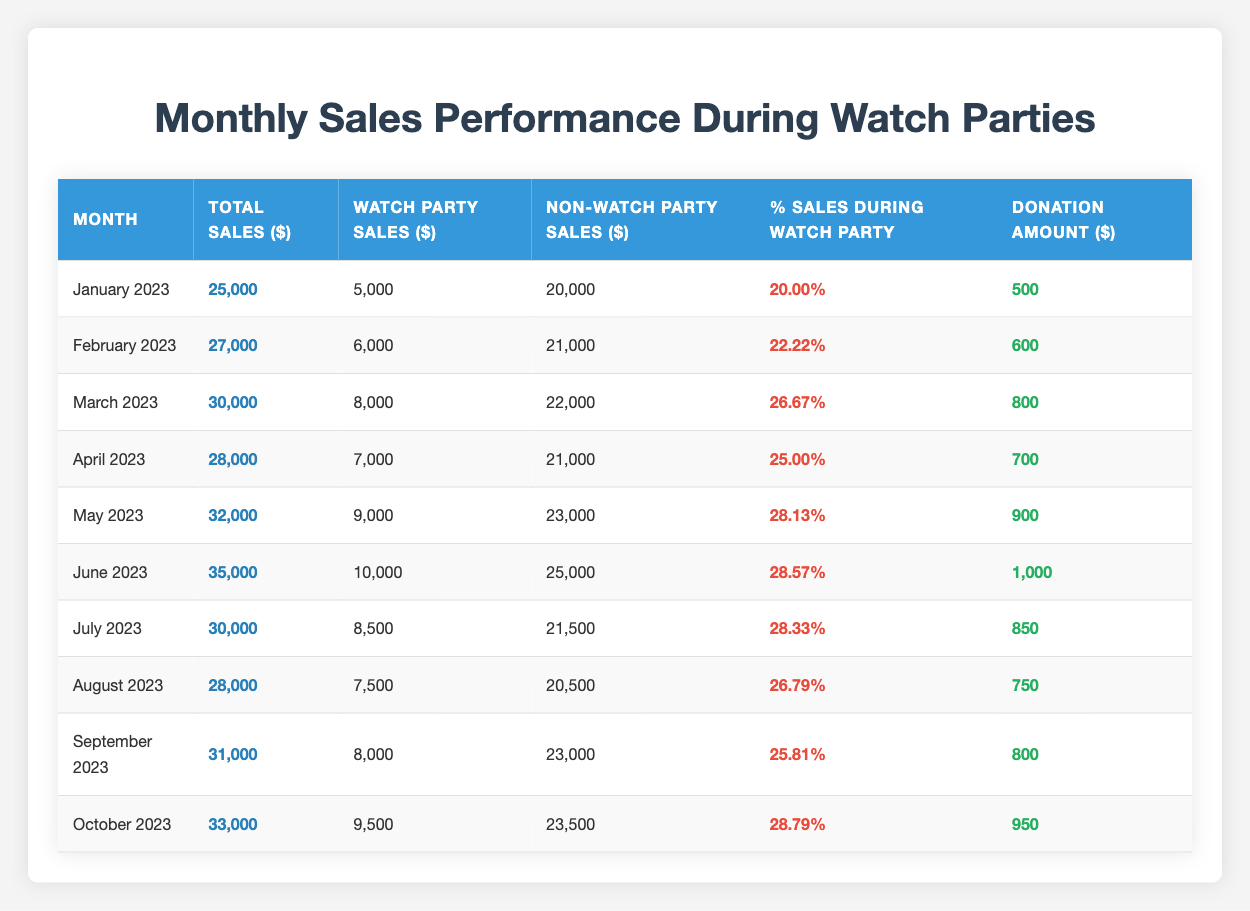What were the total sales for June 2023? In the table, find the row for June 2023, and look at the value under the Total Sales column. It indicates that the total sales for that month were 35000.
Answer: 35000 What percentage of sales during May 2023 came from watch parties? Referring to the May 2023 row in the table, the value under the % Sales During Watch Party column shows that 28.13% of the total sales came from watch parties.
Answer: 28.13% Which month had the highest watch party sales? By examining the Watch Party Sales column across all months, the maximum value is found in June 2023 with sales of 10000.
Answer: June 2023 What was the change in total sales from January 2023 to March 2023? Calculate the difference between the total sales of March 2023 (30000) and January 2023 (25000). The difference is 30000 - 25000 = 5000.
Answer: 5000 Was the donation amount for April 2023 greater than the amount for August 2023? Check the Donation Amount column for both April and August. April’s donation was 700 while August’s donation was 750. Since 700 is less than 750, the answer is no.
Answer: No What is the average donation amount over the last three months (August, September, October)? The donation amounts for these months are 750, 800, and 950 respectively. Add these amounts (750 + 800 + 950 = 2500) and divide by 3 to find the average: 2500 / 3 = 833.33.
Answer: 833.33 Is the percentage of sales during watch parties in July greater than the average percentage for the first half of the year (January to June)? The percentage for July is 28.33%. The average for the first half (add January to June percentages and divide by 6: (20 + 22.22 + 26.67 + 25 + 28.13 + 28.57) = 150.29; 150.29 / 6 = 25.05). Since 28.33% is greater than 25.05%, the answer is yes.
Answer: Yes Which month had the lowest percentage of sales during watch parties? Look through the Percentage Sales During Watch Party column. The lowest value is 20.00% from January 2023.
Answer: January 2023 What was the total sales for the months where the donation was above 800? Identify months where the donation is greater than 800 (June, July, October) and sum their total sales: 35000 + 30000 + 33000 = 98000.
Answer: 98000 